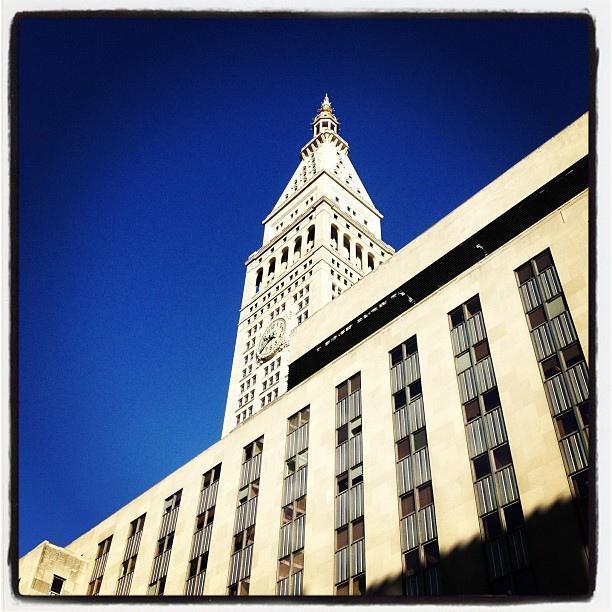How many buses are in the picture?
Give a very brief answer. 0. 